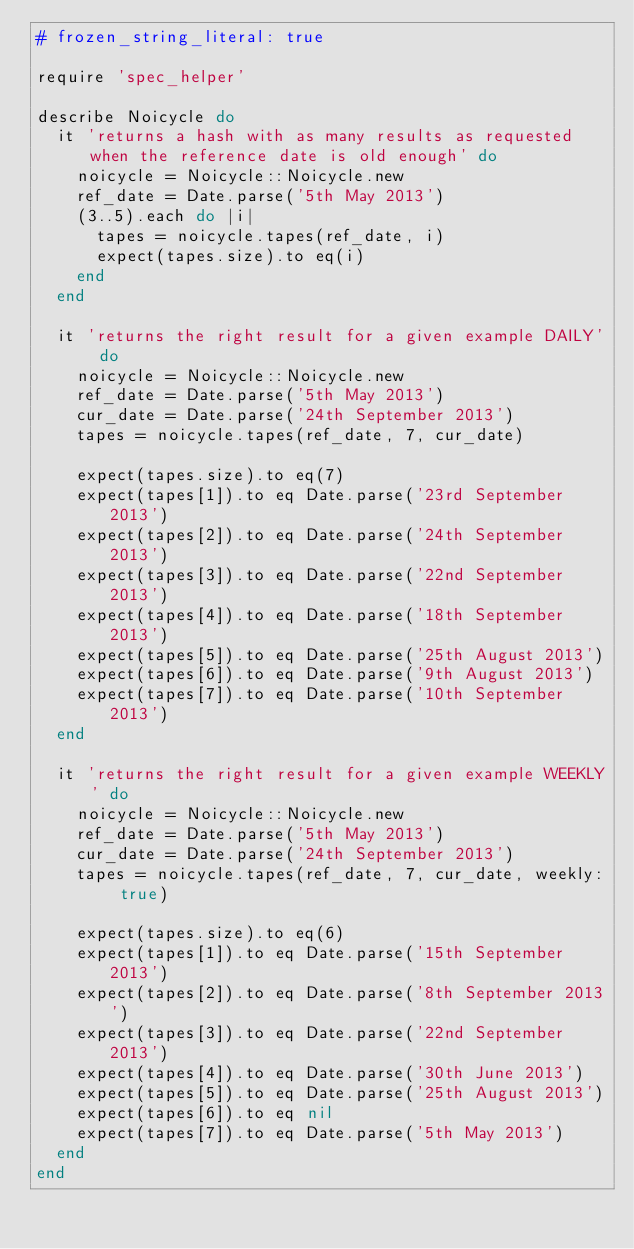Convert code to text. <code><loc_0><loc_0><loc_500><loc_500><_Ruby_># frozen_string_literal: true

require 'spec_helper'

describe Noicycle do
  it 'returns a hash with as many results as requested when the reference date is old enough' do
    noicycle = Noicycle::Noicycle.new
    ref_date = Date.parse('5th May 2013')
    (3..5).each do |i|
      tapes = noicycle.tapes(ref_date, i)
      expect(tapes.size).to eq(i)
    end
  end

  it 'returns the right result for a given example DAILY' do
    noicycle = Noicycle::Noicycle.new
    ref_date = Date.parse('5th May 2013')
    cur_date = Date.parse('24th September 2013')
    tapes = noicycle.tapes(ref_date, 7, cur_date)

    expect(tapes.size).to eq(7)
    expect(tapes[1]).to eq Date.parse('23rd September 2013')
    expect(tapes[2]).to eq Date.parse('24th September 2013')
    expect(tapes[3]).to eq Date.parse('22nd September 2013')
    expect(tapes[4]).to eq Date.parse('18th September 2013')
    expect(tapes[5]).to eq Date.parse('25th August 2013')
    expect(tapes[6]).to eq Date.parse('9th August 2013')
    expect(tapes[7]).to eq Date.parse('10th September 2013')
  end

  it 'returns the right result for a given example WEEKLY' do
    noicycle = Noicycle::Noicycle.new
    ref_date = Date.parse('5th May 2013')
    cur_date = Date.parse('24th September 2013')
    tapes = noicycle.tapes(ref_date, 7, cur_date, weekly: true)

    expect(tapes.size).to eq(6)
    expect(tapes[1]).to eq Date.parse('15th September 2013')
    expect(tapes[2]).to eq Date.parse('8th September 2013')
    expect(tapes[3]).to eq Date.parse('22nd September 2013')
    expect(tapes[4]).to eq Date.parse('30th June 2013')
    expect(tapes[5]).to eq Date.parse('25th August 2013')
    expect(tapes[6]).to eq nil
    expect(tapes[7]).to eq Date.parse('5th May 2013')
  end
end
</code> 